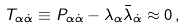Convert formula to latex. <formula><loc_0><loc_0><loc_500><loc_500>T _ { \alpha \dot { \alpha } } \equiv P _ { \alpha \dot { \alpha } } - \lambda _ { \alpha } \bar { \lambda } _ { \dot { \alpha } } \approx 0 \, ,</formula> 